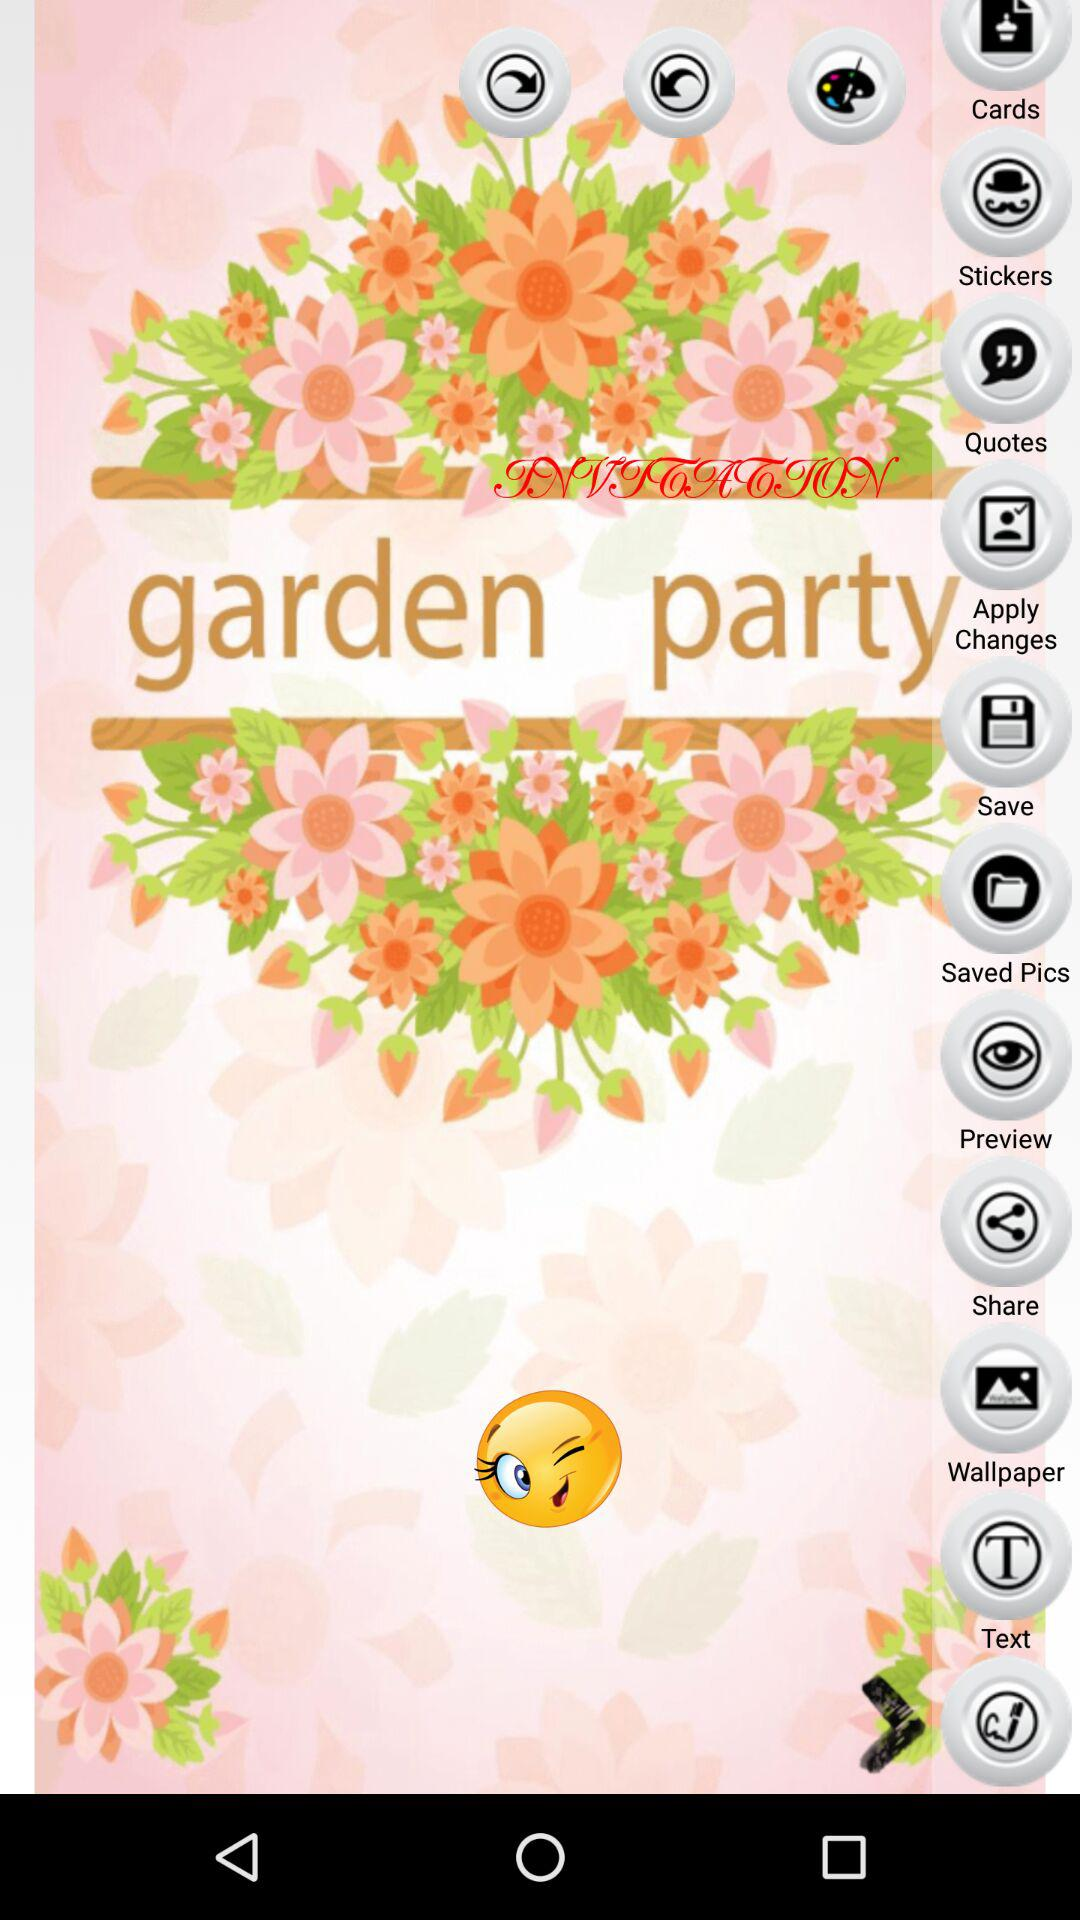What is the application name? The application name is "garden party". 